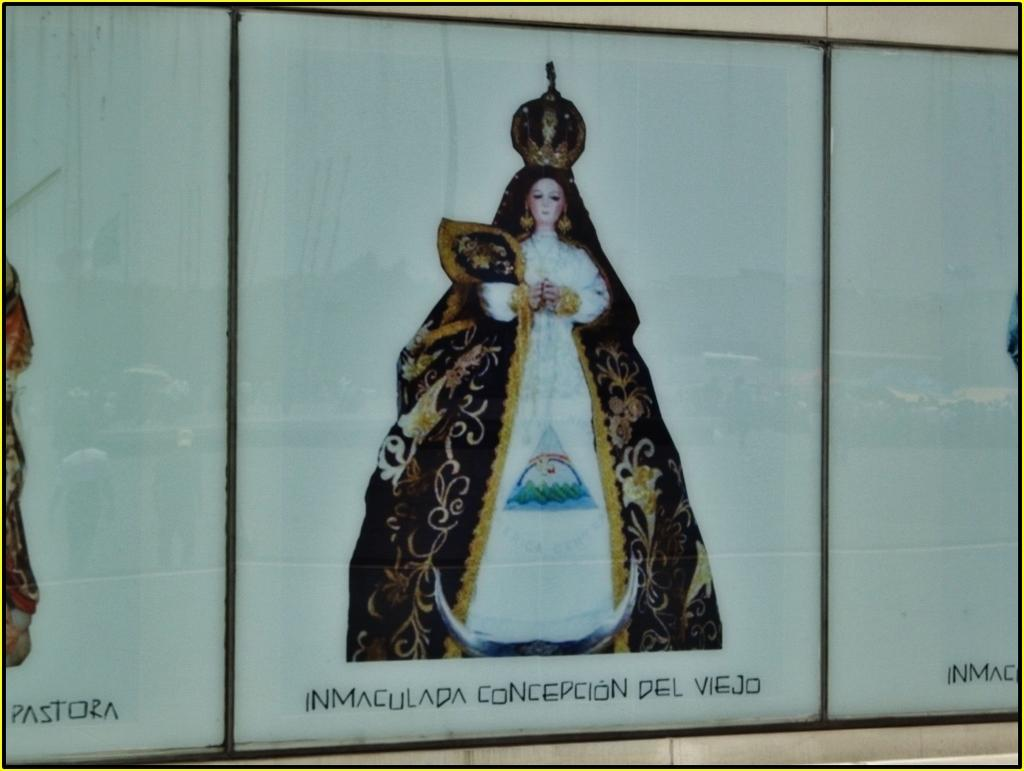What is the main subject in the center of the image? There is a depiction of a lady in the center of the image. What type of fear does the lady in the image have? There is no indication in the image of the lady having any fear, as the image only depicts a lady and does not provide any information about her emotions or thoughts. 